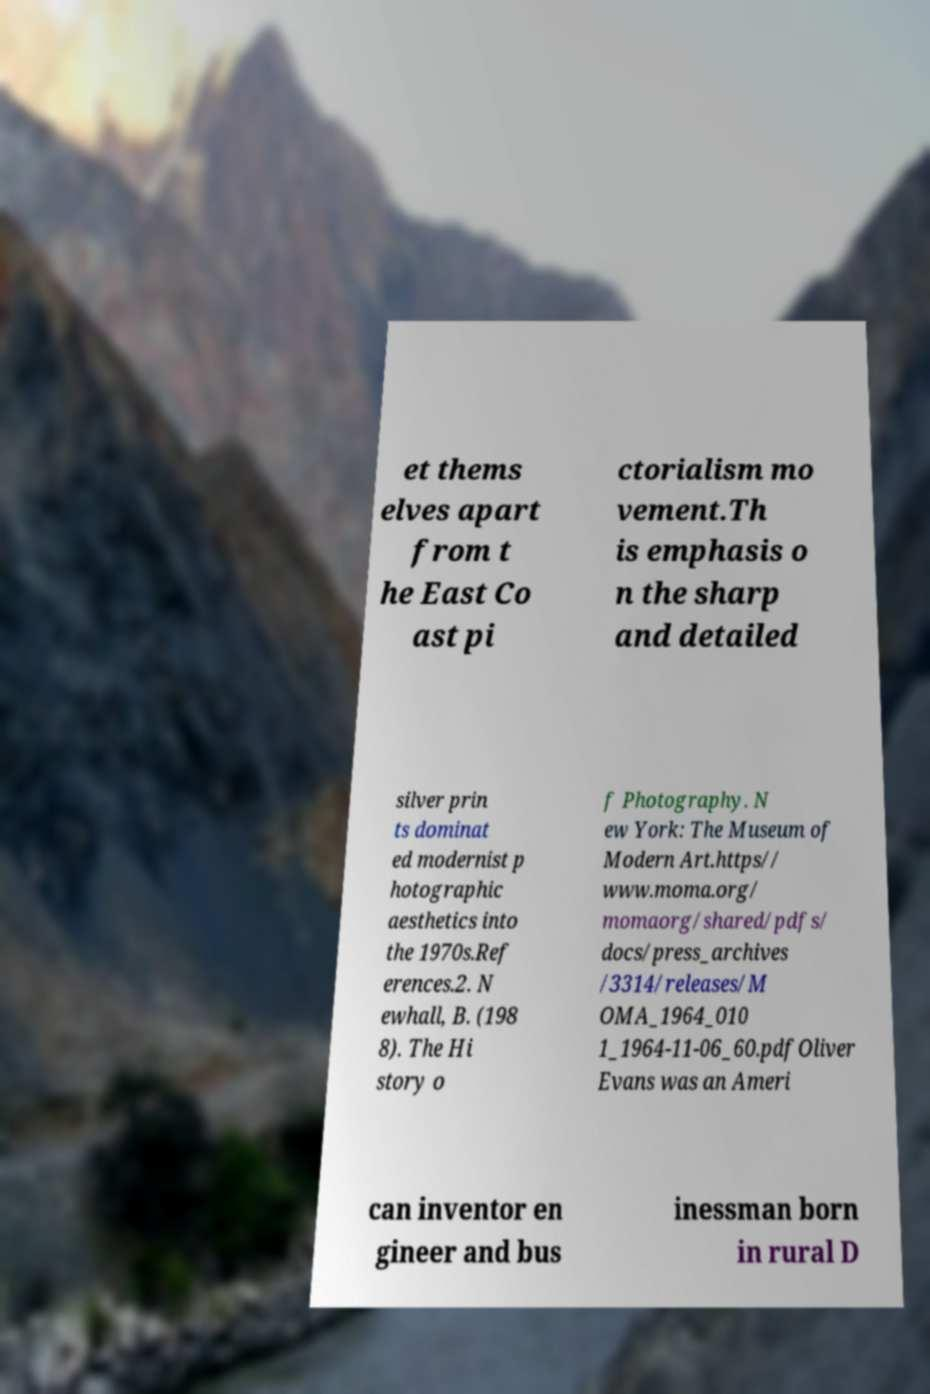Please read and relay the text visible in this image. What does it say? et thems elves apart from t he East Co ast pi ctorialism mo vement.Th is emphasis o n the sharp and detailed silver prin ts dominat ed modernist p hotographic aesthetics into the 1970s.Ref erences.2. N ewhall, B. (198 8). The Hi story o f Photography. N ew York: The Museum of Modern Art.https// www.moma.org/ momaorg/shared/pdfs/ docs/press_archives /3314/releases/M OMA_1964_010 1_1964-11-06_60.pdfOliver Evans was an Ameri can inventor en gineer and bus inessman born in rural D 